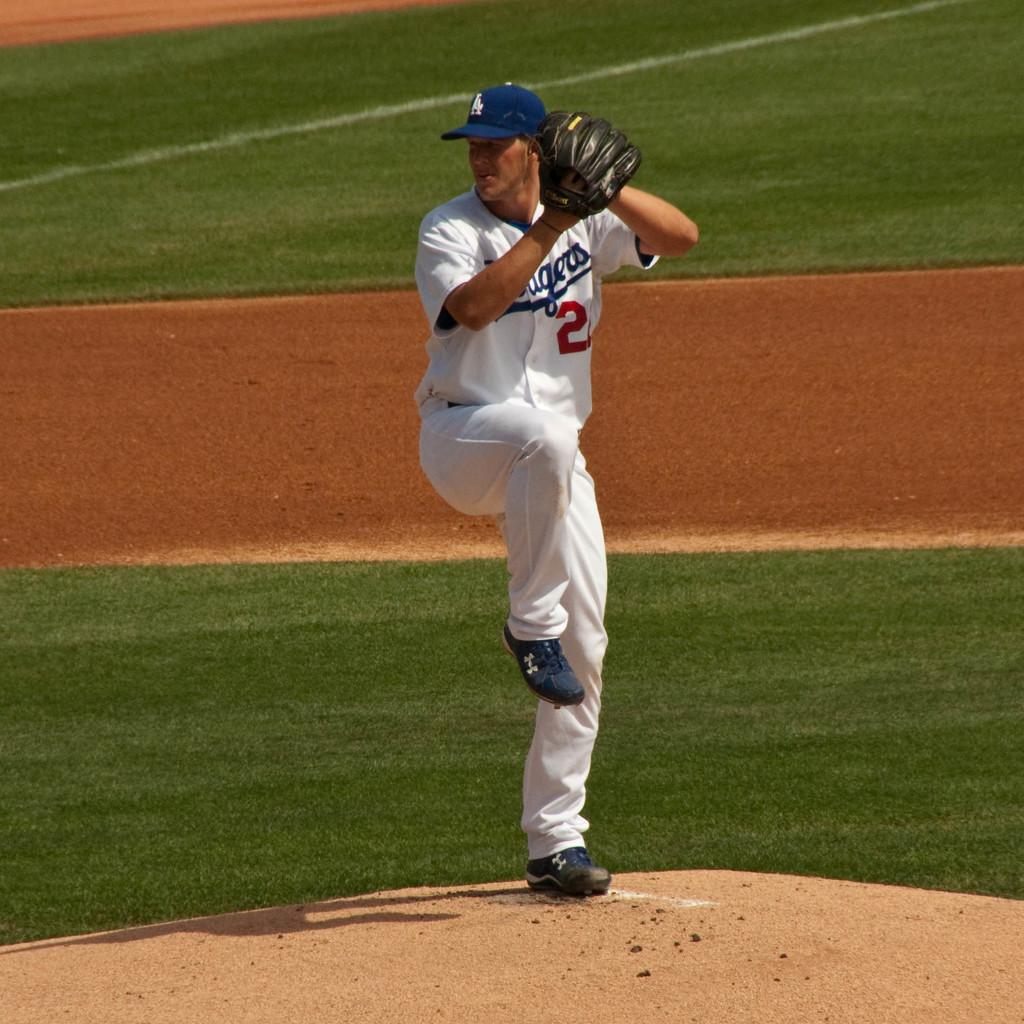Provide a one-sentence caption for the provided image. the number 2 is on the jersey of a player. 